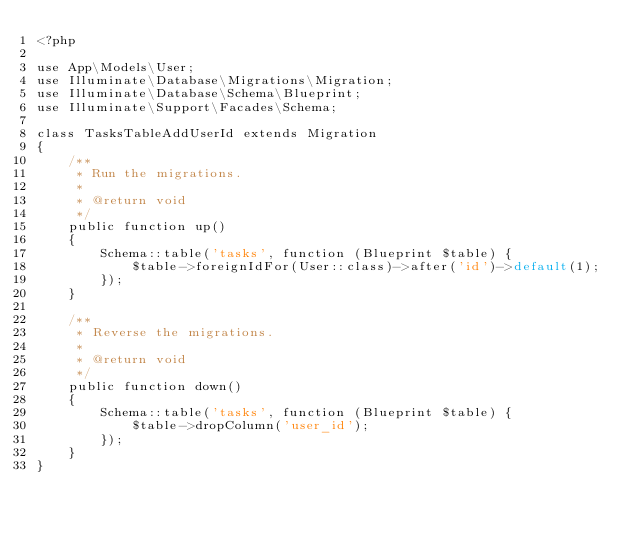<code> <loc_0><loc_0><loc_500><loc_500><_PHP_><?php

use App\Models\User;
use Illuminate\Database\Migrations\Migration;
use Illuminate\Database\Schema\Blueprint;
use Illuminate\Support\Facades\Schema;

class TasksTableAddUserId extends Migration
{
    /**
     * Run the migrations.
     *
     * @return void
     */
    public function up()
    {
        Schema::table('tasks', function (Blueprint $table) {
            $table->foreignIdFor(User::class)->after('id')->default(1);
        });
    }

    /**
     * Reverse the migrations.
     *
     * @return void
     */
    public function down()
    {
        Schema::table('tasks', function (Blueprint $table) {
            $table->dropColumn('user_id');
        });
    }
}
</code> 